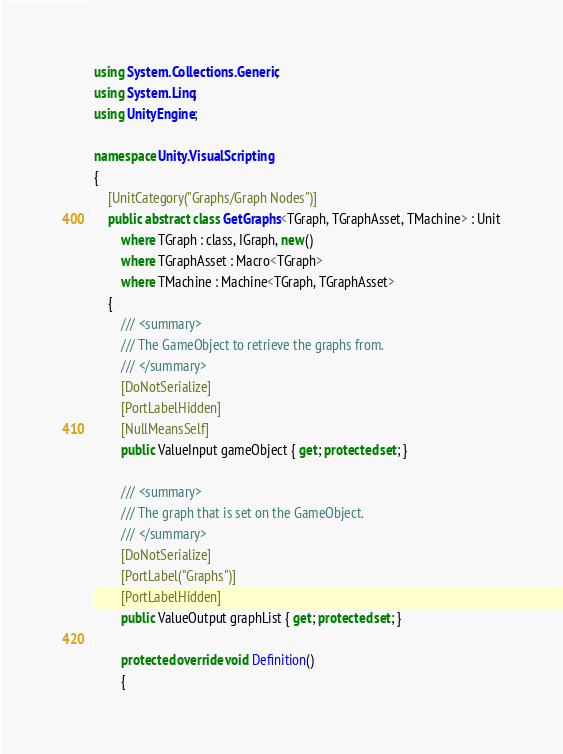<code> <loc_0><loc_0><loc_500><loc_500><_C#_>using System.Collections.Generic;
using System.Linq;
using UnityEngine;

namespace Unity.VisualScripting
{
    [UnitCategory("Graphs/Graph Nodes")]
    public abstract class GetGraphs<TGraph, TGraphAsset, TMachine> : Unit
        where TGraph : class, IGraph, new()
        where TGraphAsset : Macro<TGraph>
        where TMachine : Machine<TGraph, TGraphAsset>
    {
        /// <summary>
        /// The GameObject to retrieve the graphs from.
        /// </summary>
        [DoNotSerialize]
        [PortLabelHidden]
        [NullMeansSelf]
        public ValueInput gameObject { get; protected set; }

        /// <summary>
        /// The graph that is set on the GameObject.
        /// </summary>
        [DoNotSerialize]
        [PortLabel("Graphs")]
        [PortLabelHidden]
        public ValueOutput graphList { get; protected set; }

        protected override void Definition()
        {</code> 